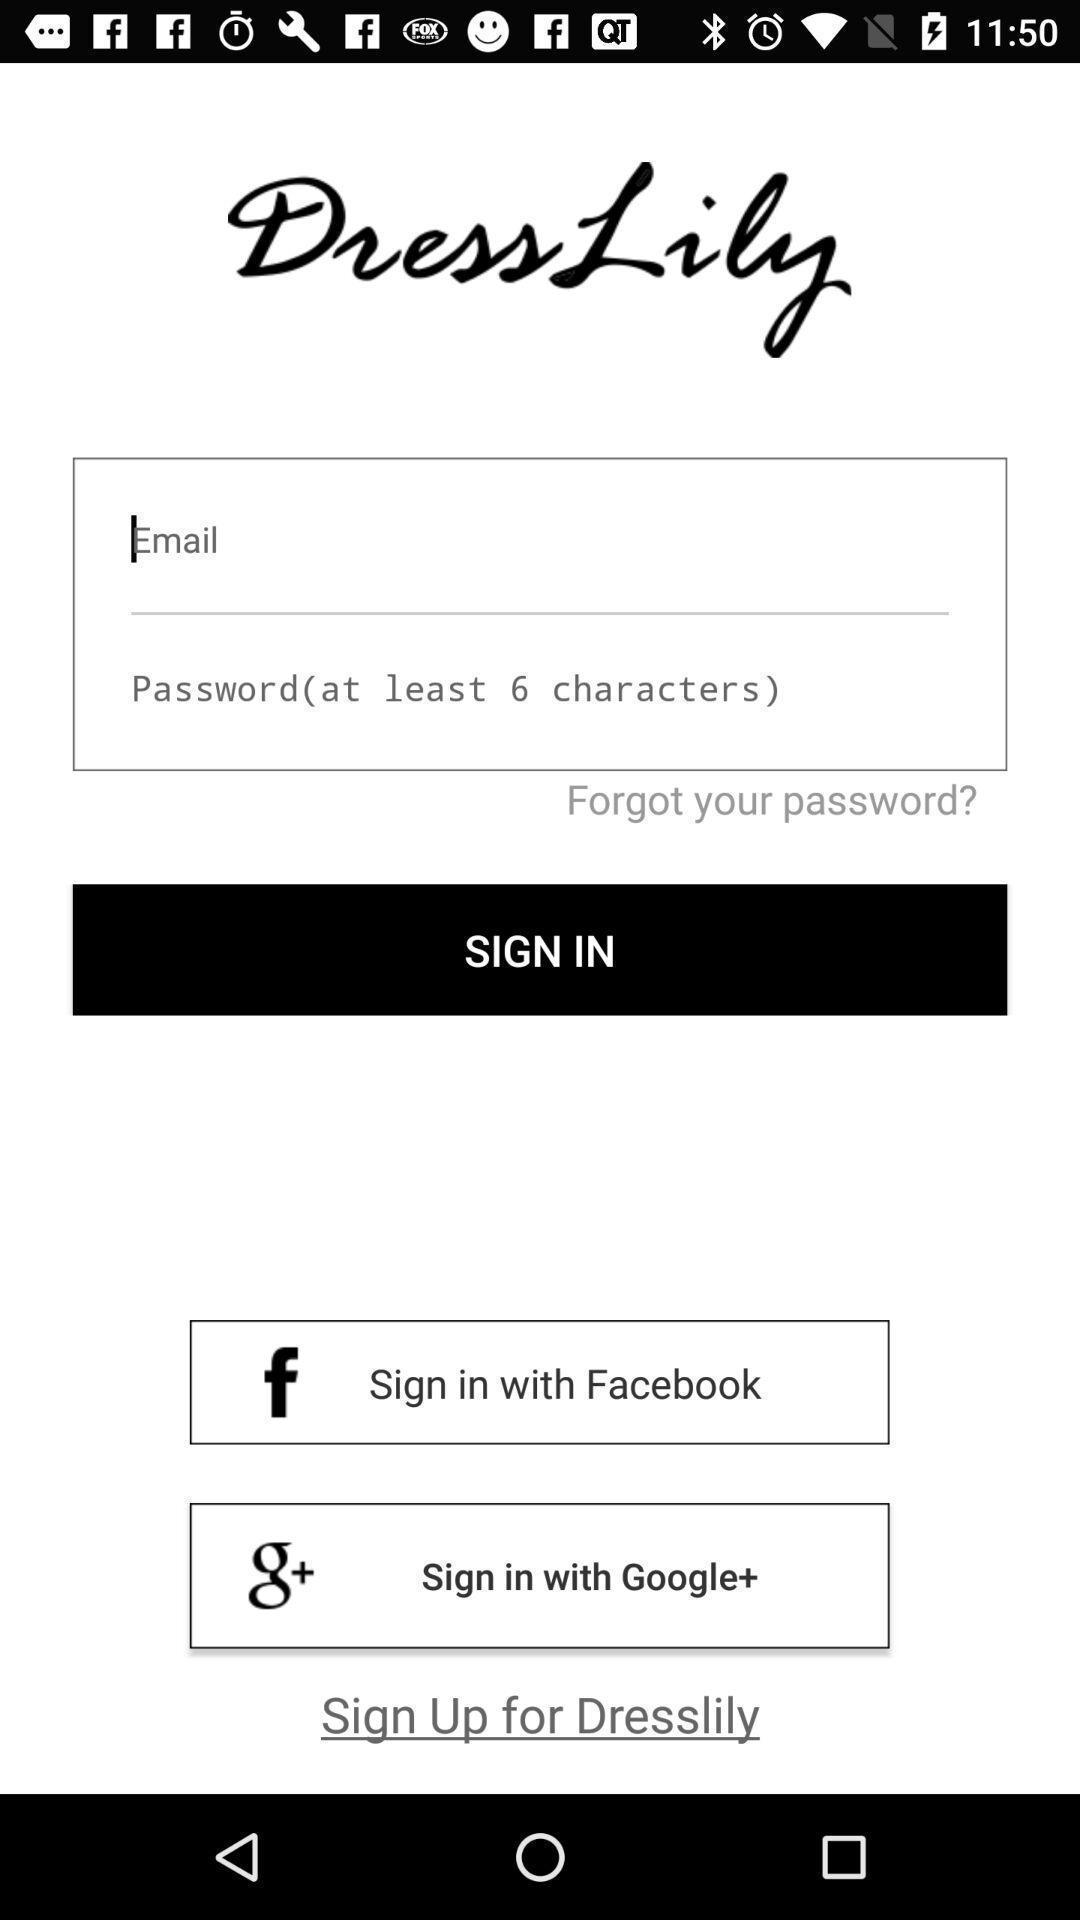Summarize the main components in this picture. Sign in page by using social application. 